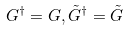<formula> <loc_0><loc_0><loc_500><loc_500>G ^ { \dagger } = G , \tilde { G } ^ { \dagger } = \tilde { G }</formula> 